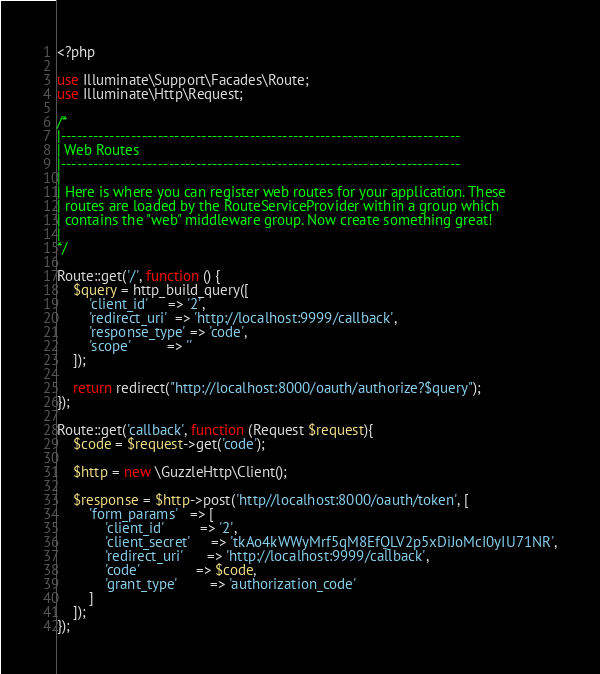<code> <loc_0><loc_0><loc_500><loc_500><_PHP_><?php

use Illuminate\Support\Facades\Route;
use Illuminate\Http\Request;

/*
|--------------------------------------------------------------------------
| Web Routes
|--------------------------------------------------------------------------
|
| Here is where you can register web routes for your application. These
| routes are loaded by the RouteServiceProvider within a group which
| contains the "web" middleware group. Now create something great!
|
*/

Route::get('/', function () {
    $query = http_build_query([
        'client_id'     => '2',
        'redirect_uri'  => 'http://localhost:9999/callback',
        'response_type' => 'code',
        'scope'         => ''
    ]);

    return redirect("http://localhost:8000/oauth/authorize?$query");
});

Route::get('callback', function (Request $request){
    $code = $request->get('code');

    $http = new \GuzzleHttp\Client();

    $response = $http->post('http//localhost:8000/oauth/token', [
        'form_params'   => [
            'client_id'         => '2',
            'client_secret'     => 'tkAo4kWWyMrf5qM8EfQLV2p5xDiJoMcI0yIU71NR',
            'redirect_uri'      => 'http://localhost:9999/callback',
            'code'              => $code,
            'grant_type'        => 'authorization_code'
        ]
    ]);
});
</code> 